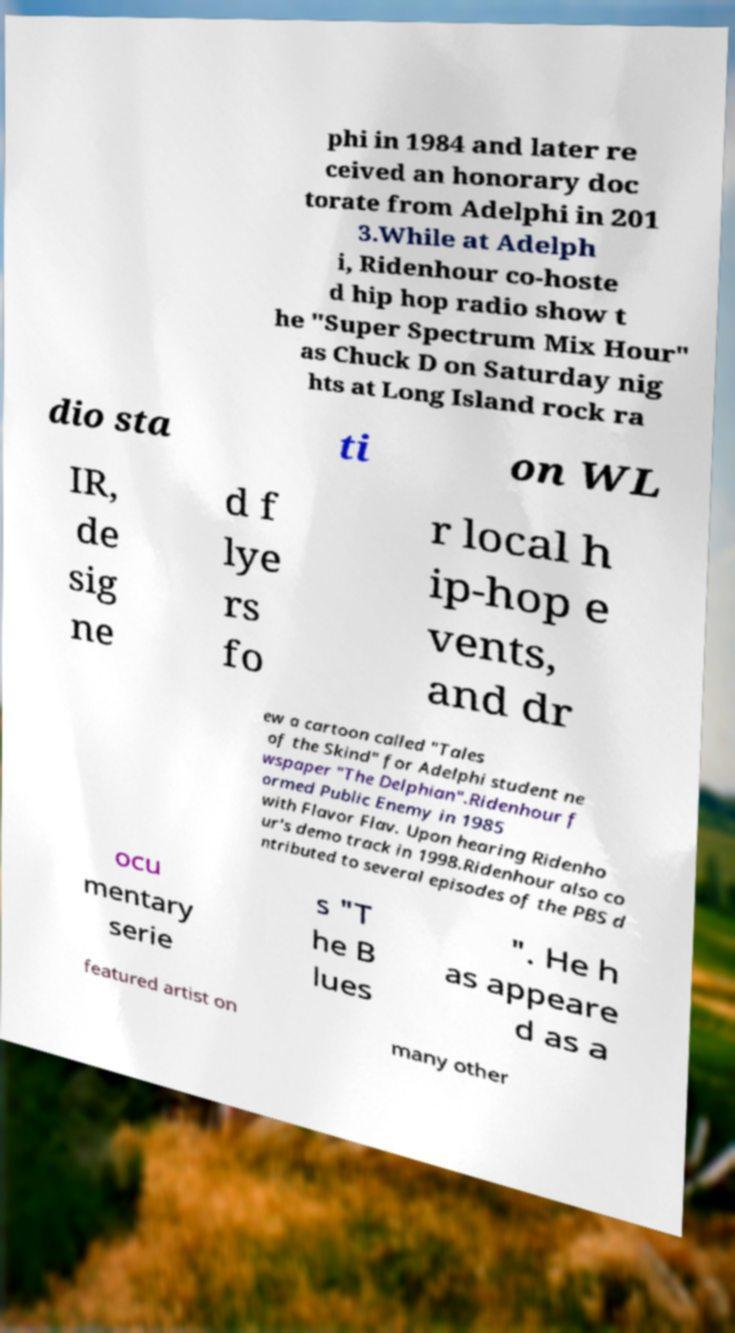Can you accurately transcribe the text from the provided image for me? phi in 1984 and later re ceived an honorary doc torate from Adelphi in 201 3.While at Adelph i, Ridenhour co-hoste d hip hop radio show t he "Super Spectrum Mix Hour" as Chuck D on Saturday nig hts at Long Island rock ra dio sta ti on WL IR, de sig ne d f lye rs fo r local h ip-hop e vents, and dr ew a cartoon called "Tales of the Skind" for Adelphi student ne wspaper "The Delphian".Ridenhour f ormed Public Enemy in 1985 with Flavor Flav. Upon hearing Ridenho ur's demo track in 1998.Ridenhour also co ntributed to several episodes of the PBS d ocu mentary serie s "T he B lues ". He h as appeare d as a featured artist on many other 